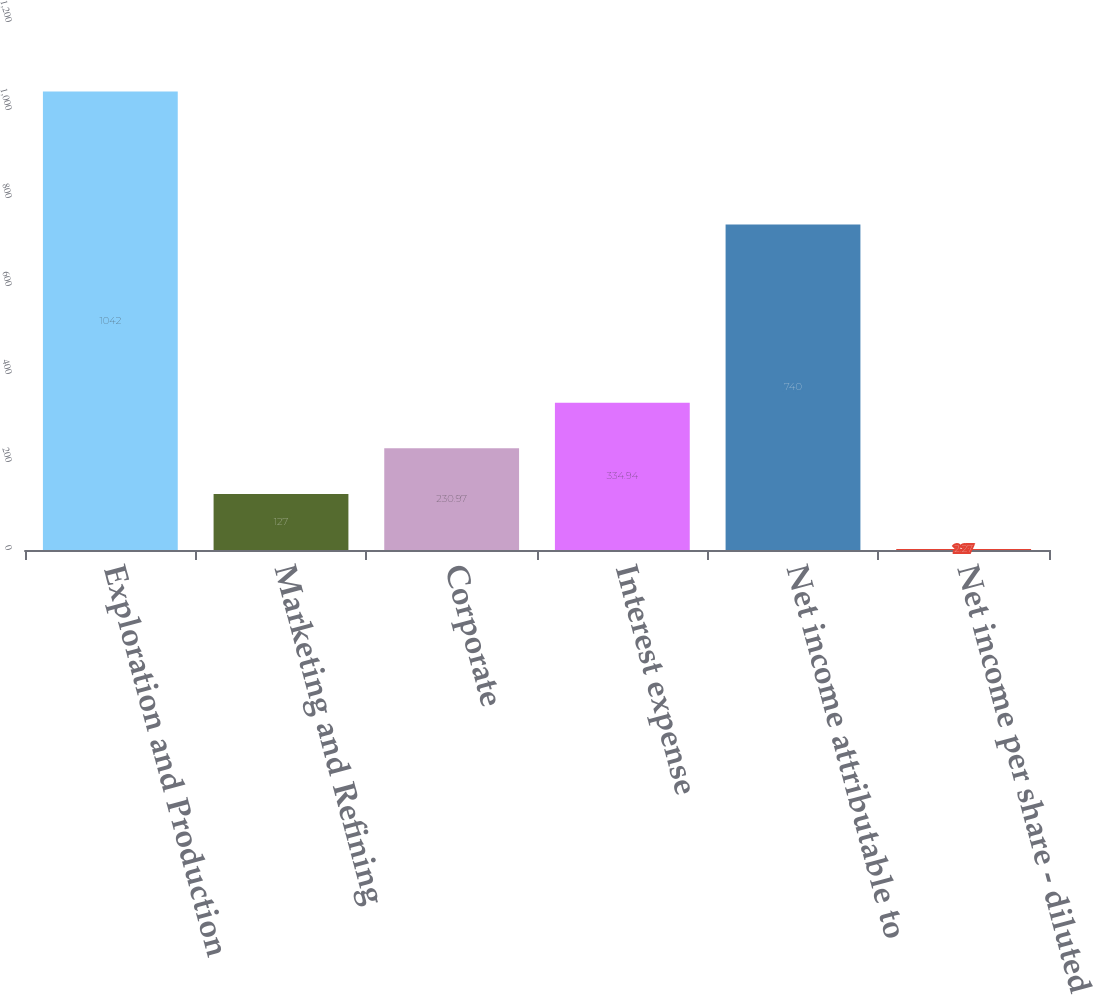Convert chart to OTSL. <chart><loc_0><loc_0><loc_500><loc_500><bar_chart><fcel>Exploration and Production<fcel>Marketing and Refining<fcel>Corporate<fcel>Interest expense<fcel>Net income attributable to<fcel>Net income per share - diluted<nl><fcel>1042<fcel>127<fcel>230.97<fcel>334.94<fcel>740<fcel>2.27<nl></chart> 